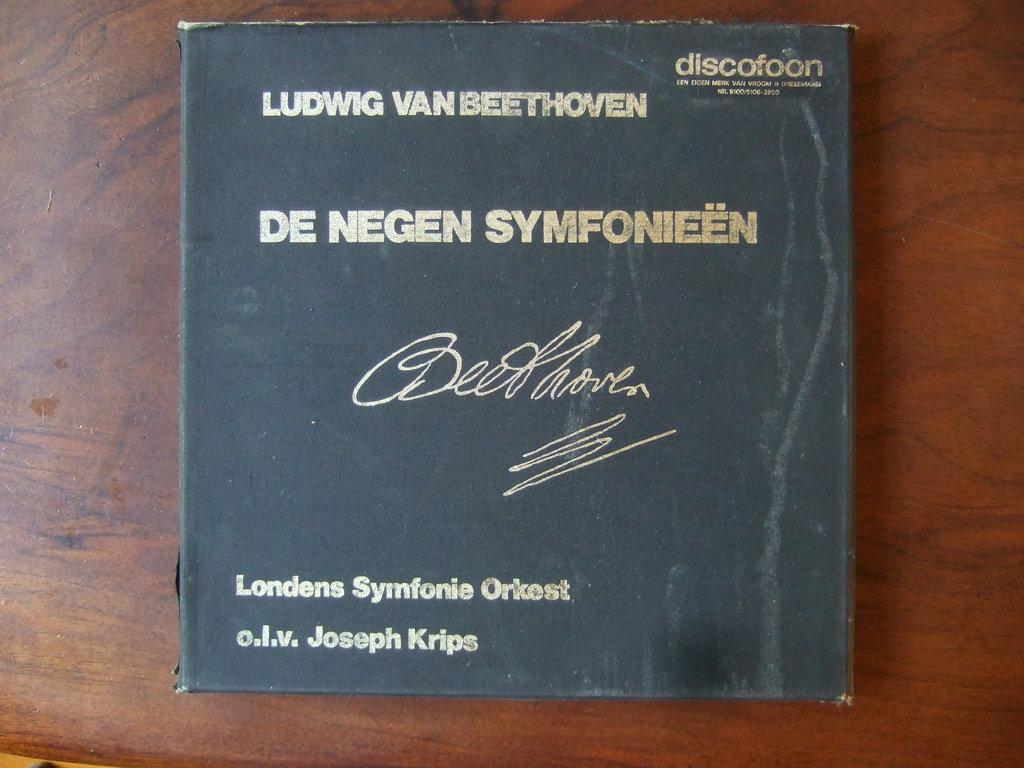What object can be seen in the image? There is a book in the image. Where is the book located? The book is placed on a wooden surface. What type of food is being prepared on the wooden surface next to the book? There is no food or any indication of food preparation in the image; it only features a book placed on a wooden surface. 